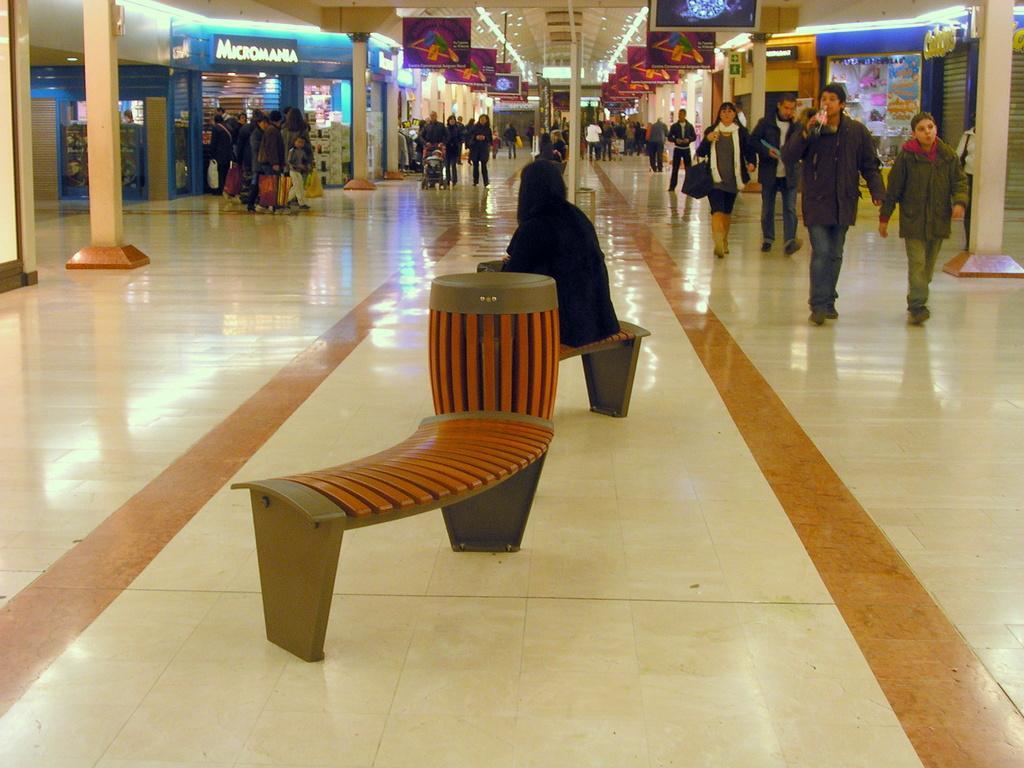In one or two sentences, can you explain what this image depicts? In this image I can see number of people are standing, I can see most of them are wearing jackets. Here I can see few benches and in the background I can see number of boards, lights, pillars and over there I can see something is written. 